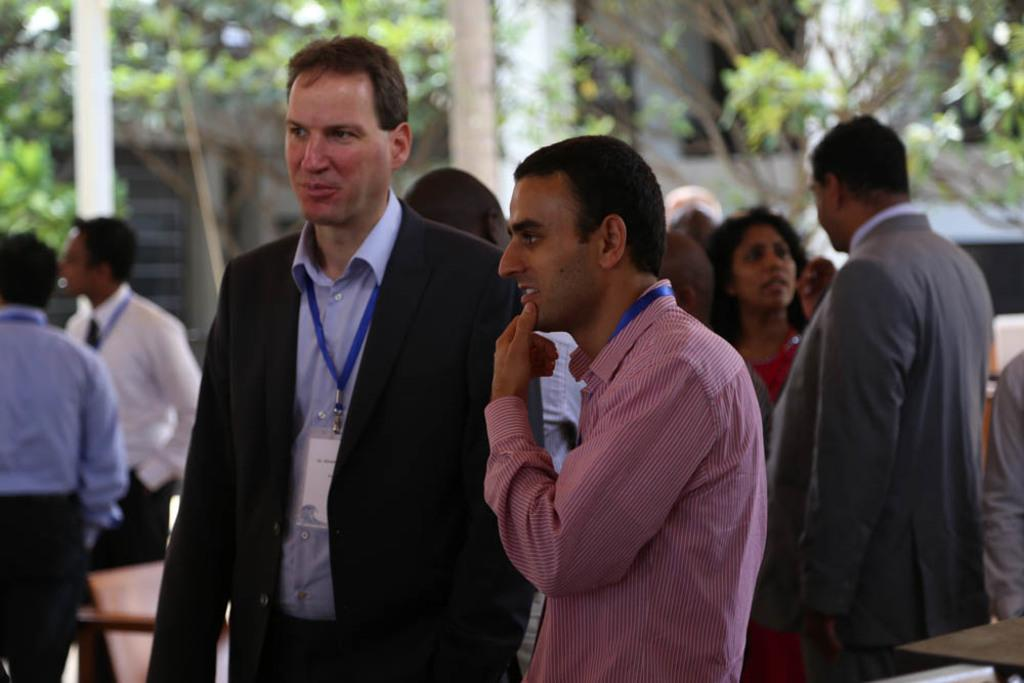Who or what is present in the image? There are people in the image. What type of furniture can be seen in the image? There is at least one chair in the image. Can you describe the background of the image? The background of the image is blurry. What type of natural scenery is visible in the background? Trees are visible in the background of the image. What type of yarn is being used to create the corn in the image? There is no yarn or corn present in the image. How many cans of paint were used to create the background in the image? The background is blurry, and there is no mention of paint or cans in the provided facts. 